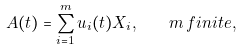<formula> <loc_0><loc_0><loc_500><loc_500>A ( t ) = \sum _ { i = 1 } ^ { m } u _ { i } ( t ) X _ { i } , \quad m \, f i n i t e ,</formula> 